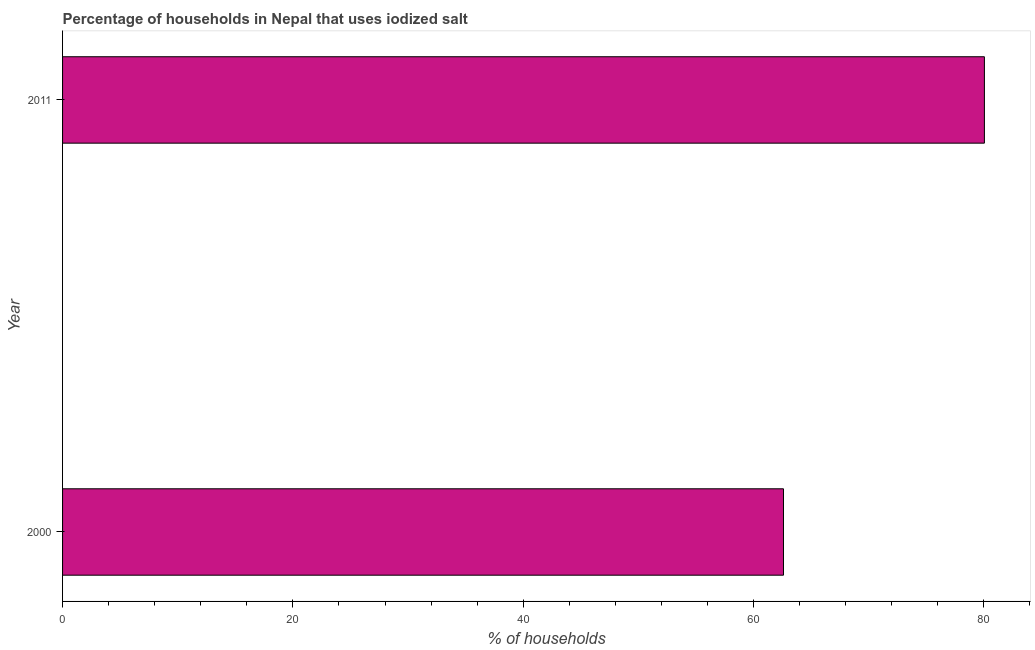Does the graph contain grids?
Provide a succinct answer. No. What is the title of the graph?
Make the answer very short. Percentage of households in Nepal that uses iodized salt. What is the label or title of the X-axis?
Keep it short and to the point. % of households. What is the percentage of households where iodized salt is consumed in 2000?
Offer a very short reply. 62.6. Across all years, what is the maximum percentage of households where iodized salt is consumed?
Make the answer very short. 80.05. Across all years, what is the minimum percentage of households where iodized salt is consumed?
Give a very brief answer. 62.6. What is the sum of the percentage of households where iodized salt is consumed?
Provide a short and direct response. 142.65. What is the difference between the percentage of households where iodized salt is consumed in 2000 and 2011?
Ensure brevity in your answer.  -17.45. What is the average percentage of households where iodized salt is consumed per year?
Offer a terse response. 71.32. What is the median percentage of households where iodized salt is consumed?
Your answer should be very brief. 71.32. Do a majority of the years between 2000 and 2011 (inclusive) have percentage of households where iodized salt is consumed greater than 68 %?
Make the answer very short. No. What is the ratio of the percentage of households where iodized salt is consumed in 2000 to that in 2011?
Provide a succinct answer. 0.78. Is the percentage of households where iodized salt is consumed in 2000 less than that in 2011?
Make the answer very short. Yes. How many bars are there?
Provide a short and direct response. 2. How many years are there in the graph?
Keep it short and to the point. 2. Are the values on the major ticks of X-axis written in scientific E-notation?
Your response must be concise. No. What is the % of households of 2000?
Your answer should be very brief. 62.6. What is the % of households in 2011?
Provide a short and direct response. 80.05. What is the difference between the % of households in 2000 and 2011?
Offer a very short reply. -17.45. What is the ratio of the % of households in 2000 to that in 2011?
Your response must be concise. 0.78. 